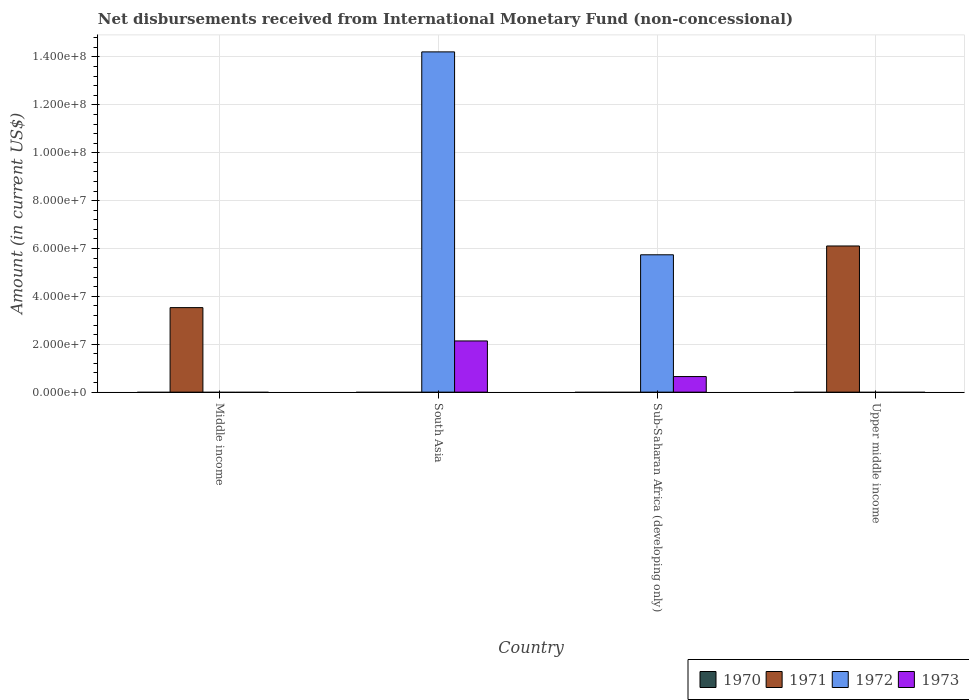Are the number of bars per tick equal to the number of legend labels?
Your answer should be very brief. No. How many bars are there on the 4th tick from the right?
Give a very brief answer. 1. What is the label of the 4th group of bars from the left?
Ensure brevity in your answer.  Upper middle income. In how many cases, is the number of bars for a given country not equal to the number of legend labels?
Keep it short and to the point. 4. What is the amount of disbursements received from International Monetary Fund in 1971 in South Asia?
Provide a short and direct response. 0. Across all countries, what is the maximum amount of disbursements received from International Monetary Fund in 1972?
Keep it short and to the point. 1.42e+08. What is the total amount of disbursements received from International Monetary Fund in 1973 in the graph?
Make the answer very short. 2.79e+07. What is the difference between the amount of disbursements received from International Monetary Fund in 1973 in South Asia and that in Sub-Saharan Africa (developing only)?
Offer a very short reply. 1.49e+07. What is the average amount of disbursements received from International Monetary Fund in 1972 per country?
Ensure brevity in your answer.  4.99e+07. What is the difference between the amount of disbursements received from International Monetary Fund of/in 1973 and amount of disbursements received from International Monetary Fund of/in 1972 in South Asia?
Provide a succinct answer. -1.21e+08. In how many countries, is the amount of disbursements received from International Monetary Fund in 1971 greater than 64000000 US$?
Your answer should be very brief. 0. What is the difference between the highest and the lowest amount of disbursements received from International Monetary Fund in 1973?
Give a very brief answer. 2.14e+07. Is it the case that in every country, the sum of the amount of disbursements received from International Monetary Fund in 1973 and amount of disbursements received from International Monetary Fund in 1970 is greater than the sum of amount of disbursements received from International Monetary Fund in 1972 and amount of disbursements received from International Monetary Fund in 1971?
Ensure brevity in your answer.  No. Is it the case that in every country, the sum of the amount of disbursements received from International Monetary Fund in 1970 and amount of disbursements received from International Monetary Fund in 1973 is greater than the amount of disbursements received from International Monetary Fund in 1971?
Offer a terse response. No. How many bars are there?
Provide a short and direct response. 6. How many countries are there in the graph?
Ensure brevity in your answer.  4. What is the difference between two consecutive major ticks on the Y-axis?
Your answer should be very brief. 2.00e+07. Are the values on the major ticks of Y-axis written in scientific E-notation?
Offer a terse response. Yes. Does the graph contain any zero values?
Offer a terse response. Yes. Does the graph contain grids?
Give a very brief answer. Yes. Where does the legend appear in the graph?
Make the answer very short. Bottom right. How many legend labels are there?
Give a very brief answer. 4. How are the legend labels stacked?
Offer a very short reply. Horizontal. What is the title of the graph?
Your answer should be compact. Net disbursements received from International Monetary Fund (non-concessional). What is the Amount (in current US$) in 1971 in Middle income?
Your answer should be very brief. 3.53e+07. What is the Amount (in current US$) of 1972 in Middle income?
Provide a succinct answer. 0. What is the Amount (in current US$) of 1971 in South Asia?
Offer a very short reply. 0. What is the Amount (in current US$) in 1972 in South Asia?
Give a very brief answer. 1.42e+08. What is the Amount (in current US$) of 1973 in South Asia?
Make the answer very short. 2.14e+07. What is the Amount (in current US$) of 1972 in Sub-Saharan Africa (developing only)?
Your response must be concise. 5.74e+07. What is the Amount (in current US$) in 1973 in Sub-Saharan Africa (developing only)?
Give a very brief answer. 6.51e+06. What is the Amount (in current US$) of 1970 in Upper middle income?
Offer a very short reply. 0. What is the Amount (in current US$) of 1971 in Upper middle income?
Give a very brief answer. 6.11e+07. Across all countries, what is the maximum Amount (in current US$) of 1971?
Give a very brief answer. 6.11e+07. Across all countries, what is the maximum Amount (in current US$) of 1972?
Give a very brief answer. 1.42e+08. Across all countries, what is the maximum Amount (in current US$) of 1973?
Offer a terse response. 2.14e+07. Across all countries, what is the minimum Amount (in current US$) of 1972?
Offer a very short reply. 0. Across all countries, what is the minimum Amount (in current US$) of 1973?
Provide a short and direct response. 0. What is the total Amount (in current US$) of 1971 in the graph?
Ensure brevity in your answer.  9.64e+07. What is the total Amount (in current US$) in 1972 in the graph?
Make the answer very short. 2.00e+08. What is the total Amount (in current US$) in 1973 in the graph?
Your answer should be very brief. 2.79e+07. What is the difference between the Amount (in current US$) of 1971 in Middle income and that in Upper middle income?
Provide a short and direct response. -2.57e+07. What is the difference between the Amount (in current US$) of 1972 in South Asia and that in Sub-Saharan Africa (developing only)?
Give a very brief answer. 8.48e+07. What is the difference between the Amount (in current US$) of 1973 in South Asia and that in Sub-Saharan Africa (developing only)?
Offer a very short reply. 1.49e+07. What is the difference between the Amount (in current US$) in 1971 in Middle income and the Amount (in current US$) in 1972 in South Asia?
Ensure brevity in your answer.  -1.07e+08. What is the difference between the Amount (in current US$) in 1971 in Middle income and the Amount (in current US$) in 1973 in South Asia?
Your answer should be very brief. 1.39e+07. What is the difference between the Amount (in current US$) of 1971 in Middle income and the Amount (in current US$) of 1972 in Sub-Saharan Africa (developing only)?
Your answer should be compact. -2.21e+07. What is the difference between the Amount (in current US$) of 1971 in Middle income and the Amount (in current US$) of 1973 in Sub-Saharan Africa (developing only)?
Your response must be concise. 2.88e+07. What is the difference between the Amount (in current US$) of 1972 in South Asia and the Amount (in current US$) of 1973 in Sub-Saharan Africa (developing only)?
Provide a short and direct response. 1.36e+08. What is the average Amount (in current US$) of 1971 per country?
Provide a succinct answer. 2.41e+07. What is the average Amount (in current US$) of 1972 per country?
Provide a short and direct response. 4.99e+07. What is the average Amount (in current US$) of 1973 per country?
Provide a short and direct response. 6.98e+06. What is the difference between the Amount (in current US$) in 1972 and Amount (in current US$) in 1973 in South Asia?
Provide a succinct answer. 1.21e+08. What is the difference between the Amount (in current US$) in 1972 and Amount (in current US$) in 1973 in Sub-Saharan Africa (developing only)?
Offer a very short reply. 5.09e+07. What is the ratio of the Amount (in current US$) in 1971 in Middle income to that in Upper middle income?
Provide a succinct answer. 0.58. What is the ratio of the Amount (in current US$) of 1972 in South Asia to that in Sub-Saharan Africa (developing only)?
Your response must be concise. 2.48. What is the ratio of the Amount (in current US$) of 1973 in South Asia to that in Sub-Saharan Africa (developing only)?
Your response must be concise. 3.29. What is the difference between the highest and the lowest Amount (in current US$) of 1971?
Provide a short and direct response. 6.11e+07. What is the difference between the highest and the lowest Amount (in current US$) of 1972?
Give a very brief answer. 1.42e+08. What is the difference between the highest and the lowest Amount (in current US$) of 1973?
Provide a short and direct response. 2.14e+07. 